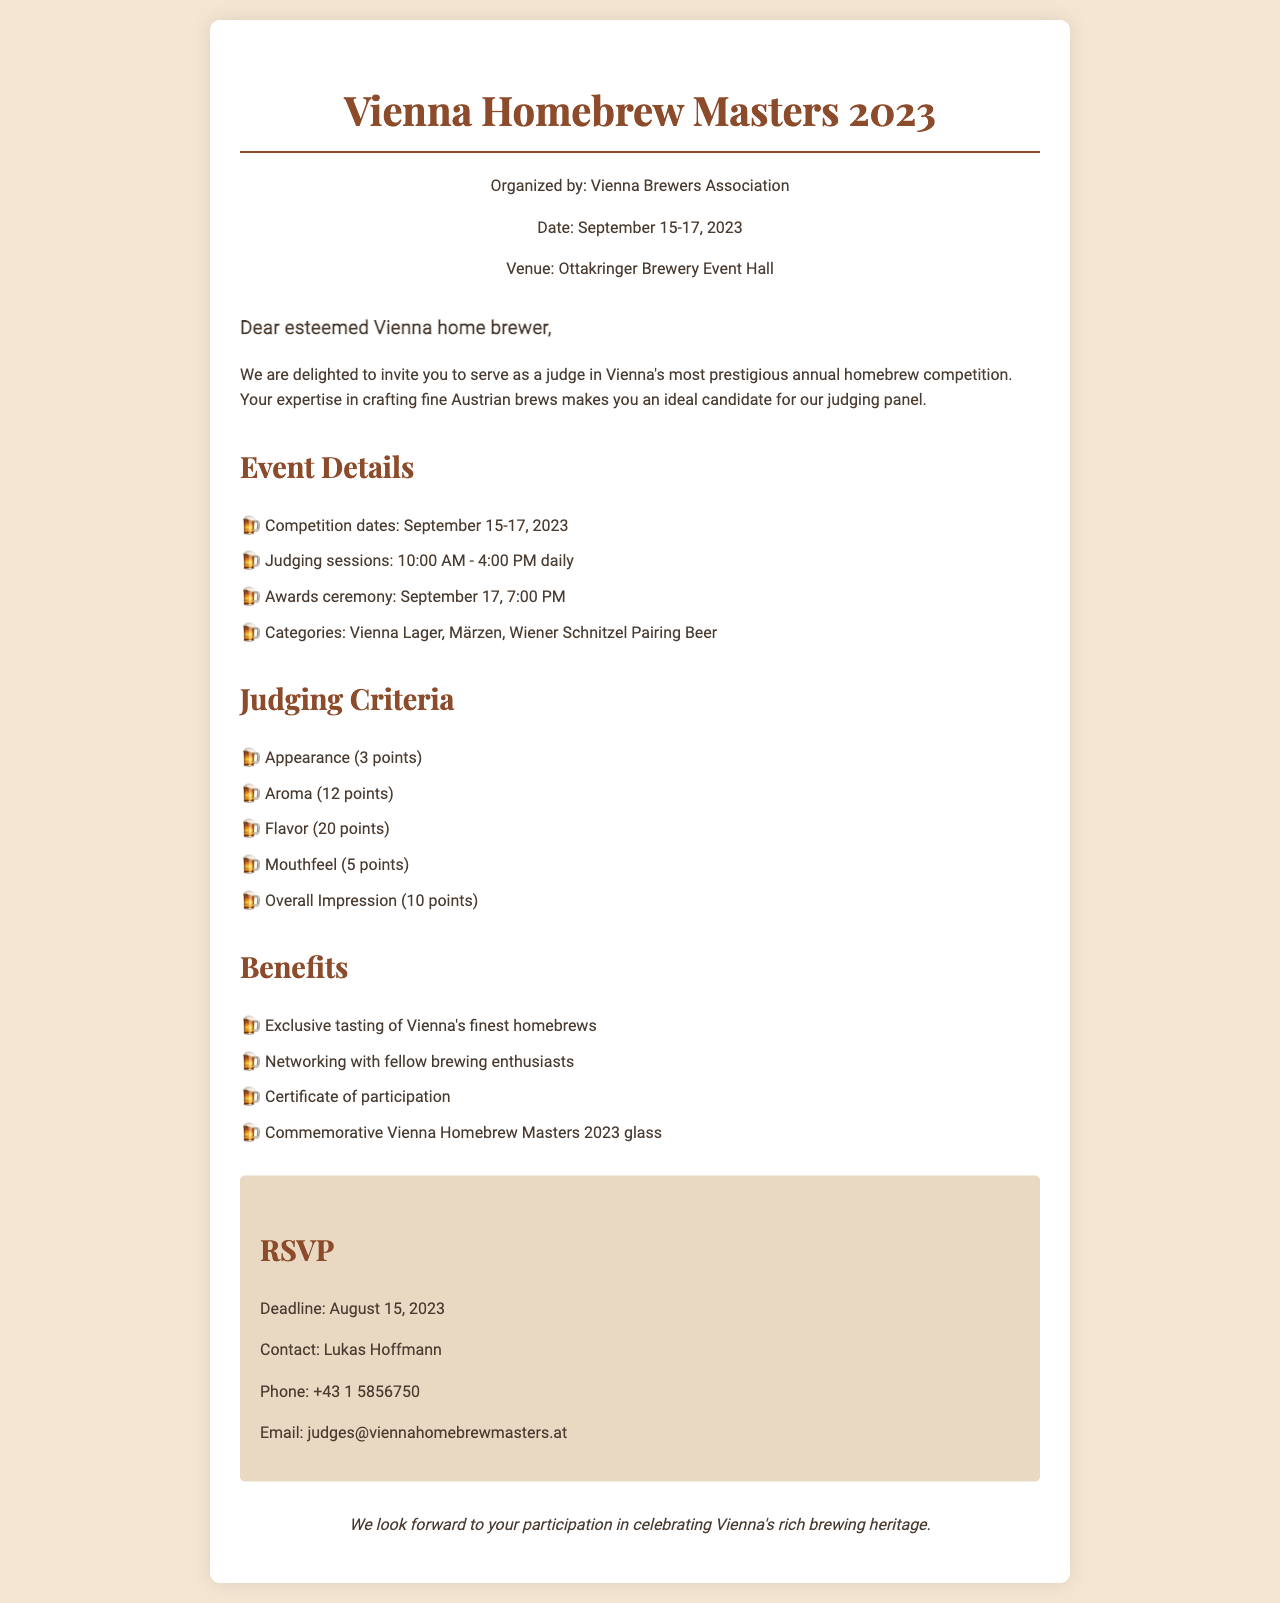What are the competition dates? The competition takes place over three days in September 2023, specifically from September 15 to September 17, 2023.
Answer: September 15-17, 2023 Who is organizing the event? The document states that the Vienna Brewers Association is the organizing body for the competition.
Answer: Vienna Brewers Association What time do the judging sessions start? According to the event details, the judging sessions begin at 10:00 AM each day.
Answer: 10:00 AM How many points is the Flavor criterion worth? The criteria list specifies that the Flavor aspect of the judging is worth 20 points.
Answer: 20 points What is one benefit of being a judge? The document outlines that one of the benefits of judging is exclusive tasting of Vienna's finest homebrews.
Answer: Exclusive tasting What is the RSVP deadline? The document clearly states that the RSVP deadline for judges is August 15, 2023.
Answer: August 15, 2023 What is the venue for the event? The document provides the location for the competition as the Ottakringer Brewery Event Hall.
Answer: Ottakringer Brewery Event Hall Name one category of beer in the competition. The document lists several categories, including Vienna Lager, which is one type of beer featured in the competition.
Answer: Vienna Lager Who should be contacted for RSVPs? The document specifies that Lukas Hoffmann is the contact person for RSVPs, indicating who to reach out to.
Answer: Lukas Hoffmann 